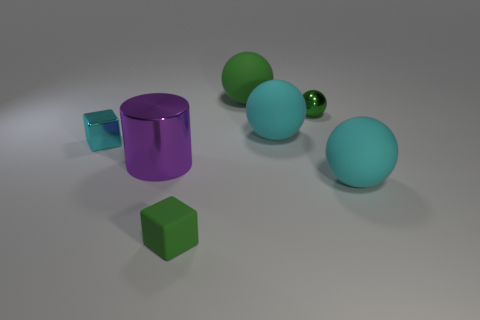Subtract all cyan balls. How many were subtracted if there are1cyan balls left? 1 Add 3 tiny green things. How many objects exist? 10 Subtract all green matte balls. How many balls are left? 3 Subtract all green spheres. How many spheres are left? 2 Subtract all cylinders. How many objects are left? 6 Subtract all blue blocks. How many green spheres are left? 2 Subtract all tiny red matte objects. Subtract all shiny cubes. How many objects are left? 6 Add 3 tiny balls. How many tiny balls are left? 4 Add 3 cyan metallic cubes. How many cyan metallic cubes exist? 4 Subtract 0 red blocks. How many objects are left? 7 